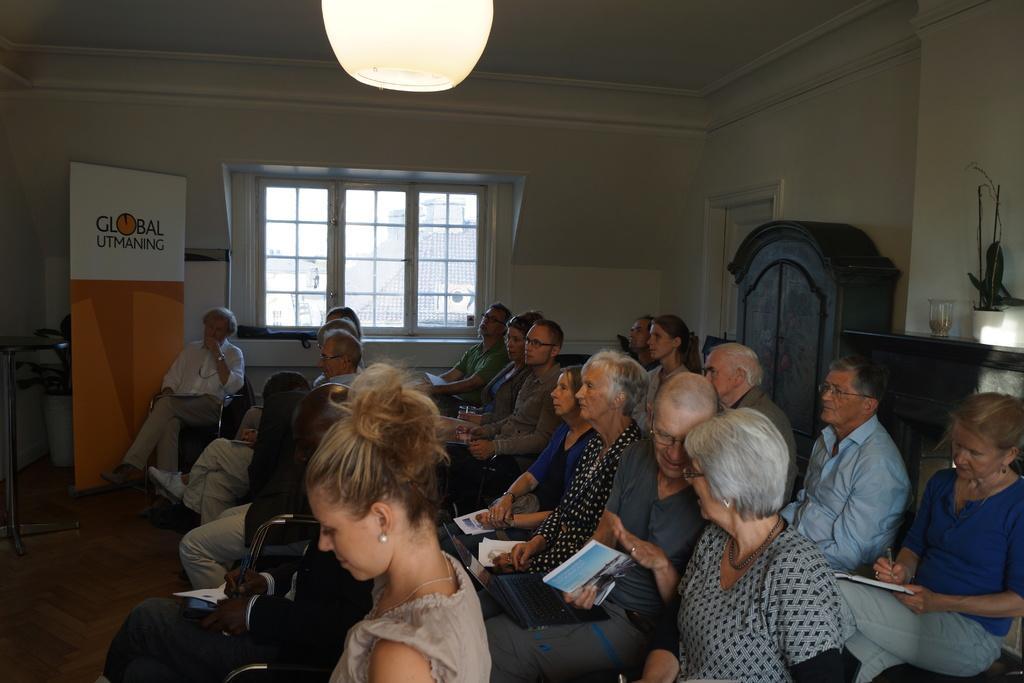Could you give a brief overview of what you see in this image? This is an inside view of a room. Here I can see many people are sitting on the chairs facing towards the left side. Everyone are holding some books in their hands. On the right side there is a table on which glass and some other objects are placed. Beside that I can see a cupboard and also there is a door to the wall. In the background there is a window. Beside the window I can see a banner and which is placed on the floor. On the top I can see a lantern. 